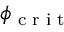Convert formula to latex. <formula><loc_0><loc_0><loc_500><loc_500>\phi _ { c r i t }</formula> 